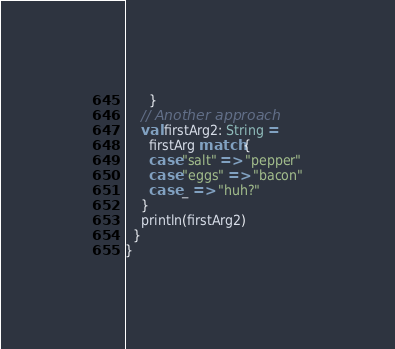<code> <loc_0><loc_0><loc_500><loc_500><_Scala_>      }
    // Another approach
    val firstArg2: String = 
      firstArg match {
      case "salt" => "pepper"
      case "eggs" => "bacon"
      case _ => "huh?"
    }
    println(firstArg2)
  }
}</code> 